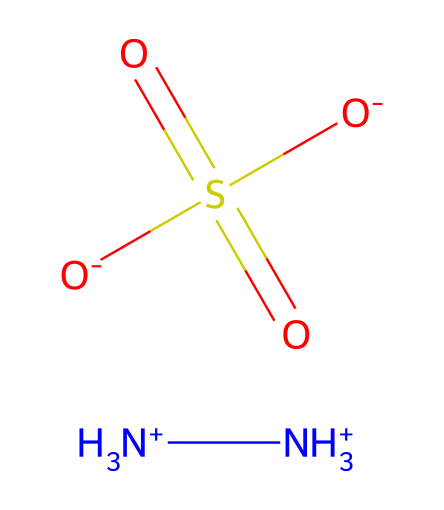what is the molecular formula of hydrazine sulfate? The SMILES representation includes nitrogen (N) and sulfur (S) atoms, as well as oxygen (O) atoms. Counting each atom presents the formula as N2H8O4S.
Answer: N2H8O4S how many nitrogen atoms are in hydrazine sulfate? In the provided SMILES representation, there are two [NH3+] groups, which indicate two nitrogen atoms.
Answer: 2 what is the charge of the sulfate ion in this compound? The sulfate ion portion of the structure includes a negatively charged oxygen and is typically represented as SO4^2-; thus, the charge is -2.
Answer: -2 how many oxygen atoms are connected to the sulfur atom? The SMILES notation shows the sulfur atom is central to three oxygen atoms shown as [O-] and part of the sulfate group, which confirms the connectivity to four.
Answer: 4 what type of reaction might hydrazine sulfate inhibit that relates to corrosion in infrastructure? Hydrazine sulfate has anti-corrosive properties, primarily due to its ability to neutralize oxidation reactions that can lead to rust and deterioration of metal surfaces in infrastructure.
Answer: oxidation reactions what makes hydrazine and its derivatives significant in terms of sustainable transportation? Hydrazine and its derivatives, such as hydrazine sulfate, are important as they can be used as fuel in clean energy technologies and engines. Their reduced environmental impact supports sustainable transportation goals.
Answer: fuel in clean energy technologies 